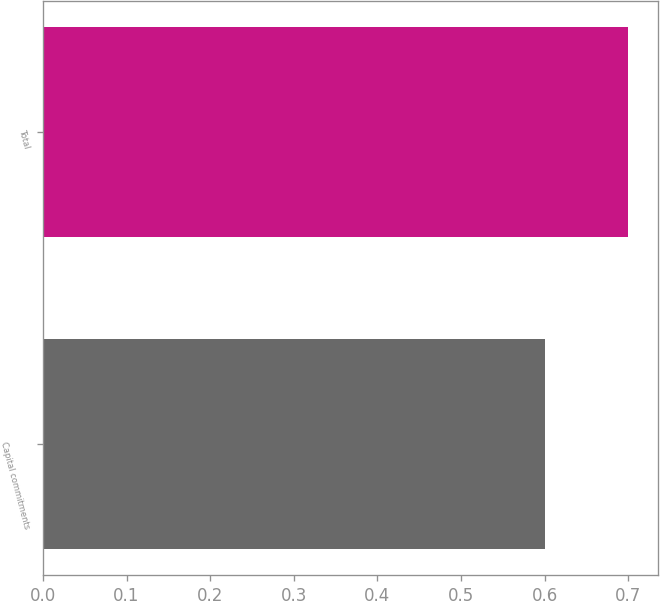Convert chart. <chart><loc_0><loc_0><loc_500><loc_500><bar_chart><fcel>Capital commitments<fcel>Total<nl><fcel>0.6<fcel>0.7<nl></chart> 